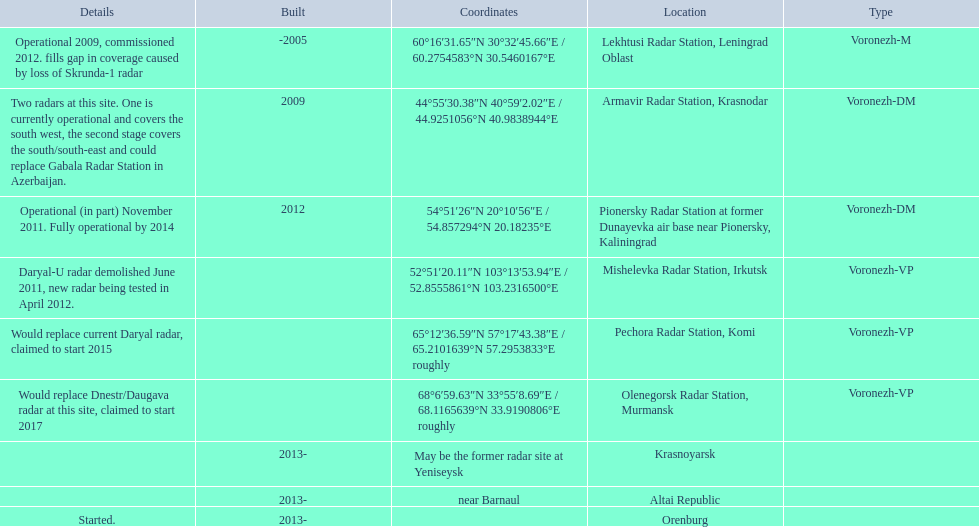Where is each radar? Lekhtusi Radar Station, Leningrad Oblast, Armavir Radar Station, Krasnodar, Pionersky Radar Station at former Dunayevka air base near Pionersky, Kaliningrad, Mishelevka Radar Station, Irkutsk, Pechora Radar Station, Komi, Olenegorsk Radar Station, Murmansk, Krasnoyarsk, Altai Republic, Orenburg. What are the details of each radar? Operational 2009, commissioned 2012. fills gap in coverage caused by loss of Skrunda-1 radar, Two radars at this site. One is currently operational and covers the south west, the second stage covers the south/south-east and could replace Gabala Radar Station in Azerbaijan., Operational (in part) November 2011. Fully operational by 2014, Daryal-U radar demolished June 2011, new radar being tested in April 2012., Would replace current Daryal radar, claimed to start 2015, Would replace Dnestr/Daugava radar at this site, claimed to start 2017, , , Started. Which radar is detailed to start in 2015? Pechora Radar Station, Komi. 